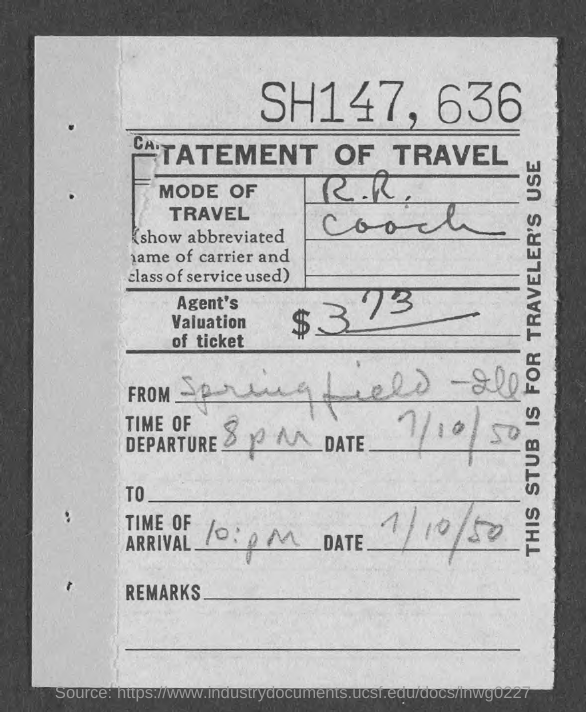What is the value of agent's ticket?
Your response must be concise. $373. What is the currency?
Make the answer very short. $. What is the time of departure?
Offer a very short reply. 8 pm. What is the date?
Your response must be concise. 7/10/50. 